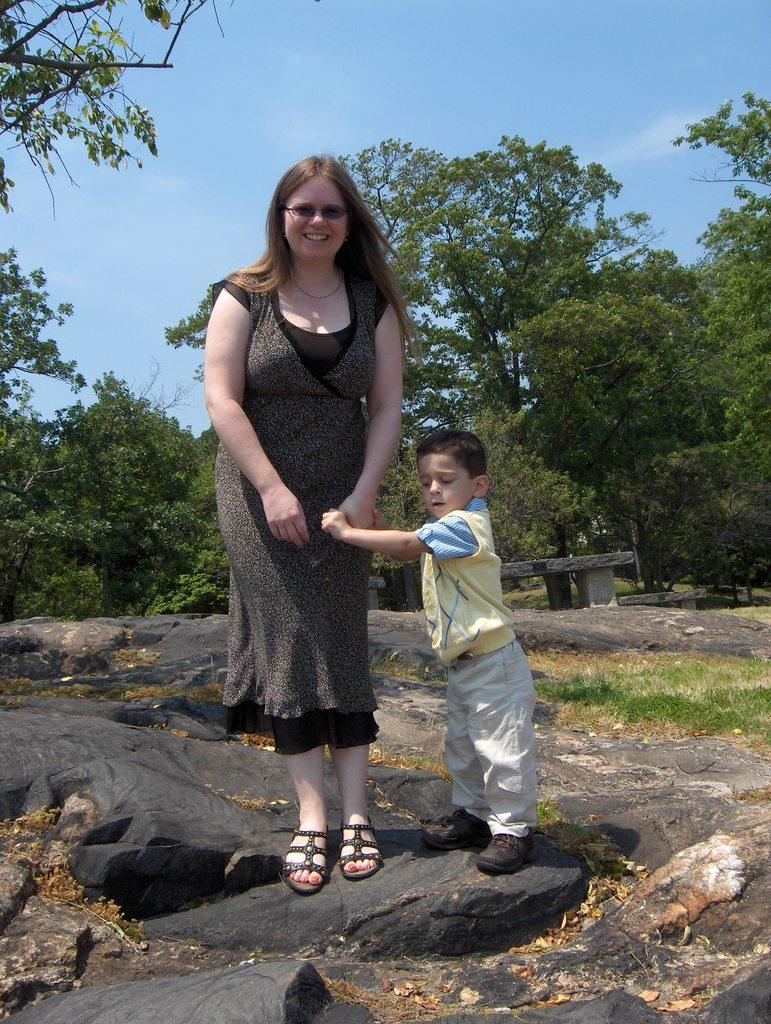Who are the people in the image? There is a woman and a kid in the image. Where are they standing? They are standing on a rock. What can be seen in the background of the image? There is a bench, trees, grass, and the sky visible in the background of the image. What is the condition of the sky in the image? Clouds are visible in the sky. What type of produce is being harvested by the woman and kid in the image? There is no produce or harvesting activity depicted in the image; they are simply standing on a rock. What type of iron object can be seen in the image? There is no iron object present in the image. 